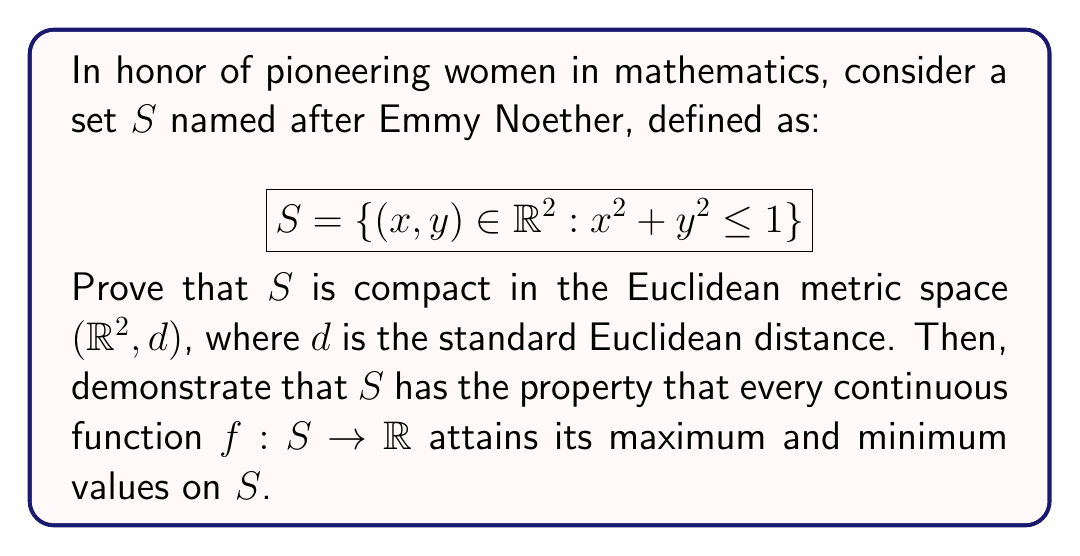Teach me how to tackle this problem. To prove that $S$ is compact and has the stated property, we'll follow these steps:

1) Prove $S$ is compact:
   a) Show $S$ is closed
   b) Show $S$ is bounded

2) Demonstrate the property for continuous functions on $S$

Step 1a: $S$ is closed
- $S$ is the preimage of the closed interval $[0,1]$ under the continuous function $g(x,y) = x^2 + y^2$
- The preimage of a closed set under a continuous function is closed
- Therefore, $S$ is closed

Step 1b: $S$ is bounded
- For any $(x,y) \in S$, we have $x^2 + y^2 \leq 1$
- This implies $-1 \leq x \leq 1$ and $-1 \leq y \leq 1$
- Therefore, $S$ is contained in the square $[-1,1] \times [-1,1]$
- Hence, $S$ is bounded

Since $S$ is both closed and bounded in $\mathbb{R}^2$, by the Heine-Borel theorem, $S$ is compact.

Step 2: Property for continuous functions
- Let $f: S \rightarrow \mathbb{R}$ be a continuous function
- $S$ is compact (proved in step 1)
- By the extreme value theorem, every continuous function on a compact set attains its maximum and minimum values
- Therefore, $f$ attains its maximum and minimum values on $S$

This property is particularly important in optimization problems and has applications in various fields of STEM, including engineering and computer science.
Answer: $S$ is compact in $(\mathbb{R}^2, d)$, and every continuous function $f: S \rightarrow \mathbb{R}$ attains its maximum and minimum values on $S$. 